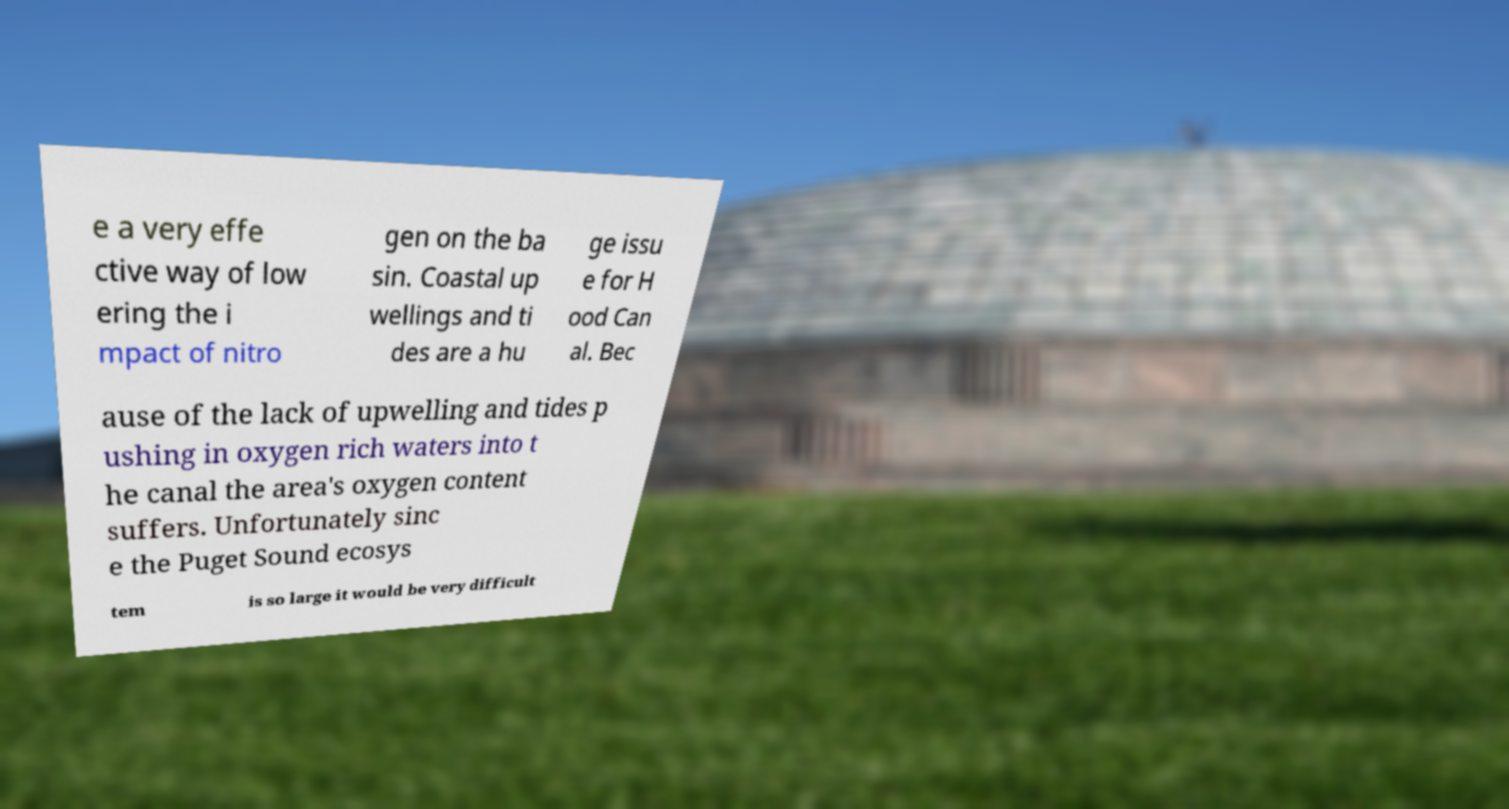Could you extract and type out the text from this image? e a very effe ctive way of low ering the i mpact of nitro gen on the ba sin. Coastal up wellings and ti des are a hu ge issu e for H ood Can al. Bec ause of the lack of upwelling and tides p ushing in oxygen rich waters into t he canal the area's oxygen content suffers. Unfortunately sinc e the Puget Sound ecosys tem is so large it would be very difficult 